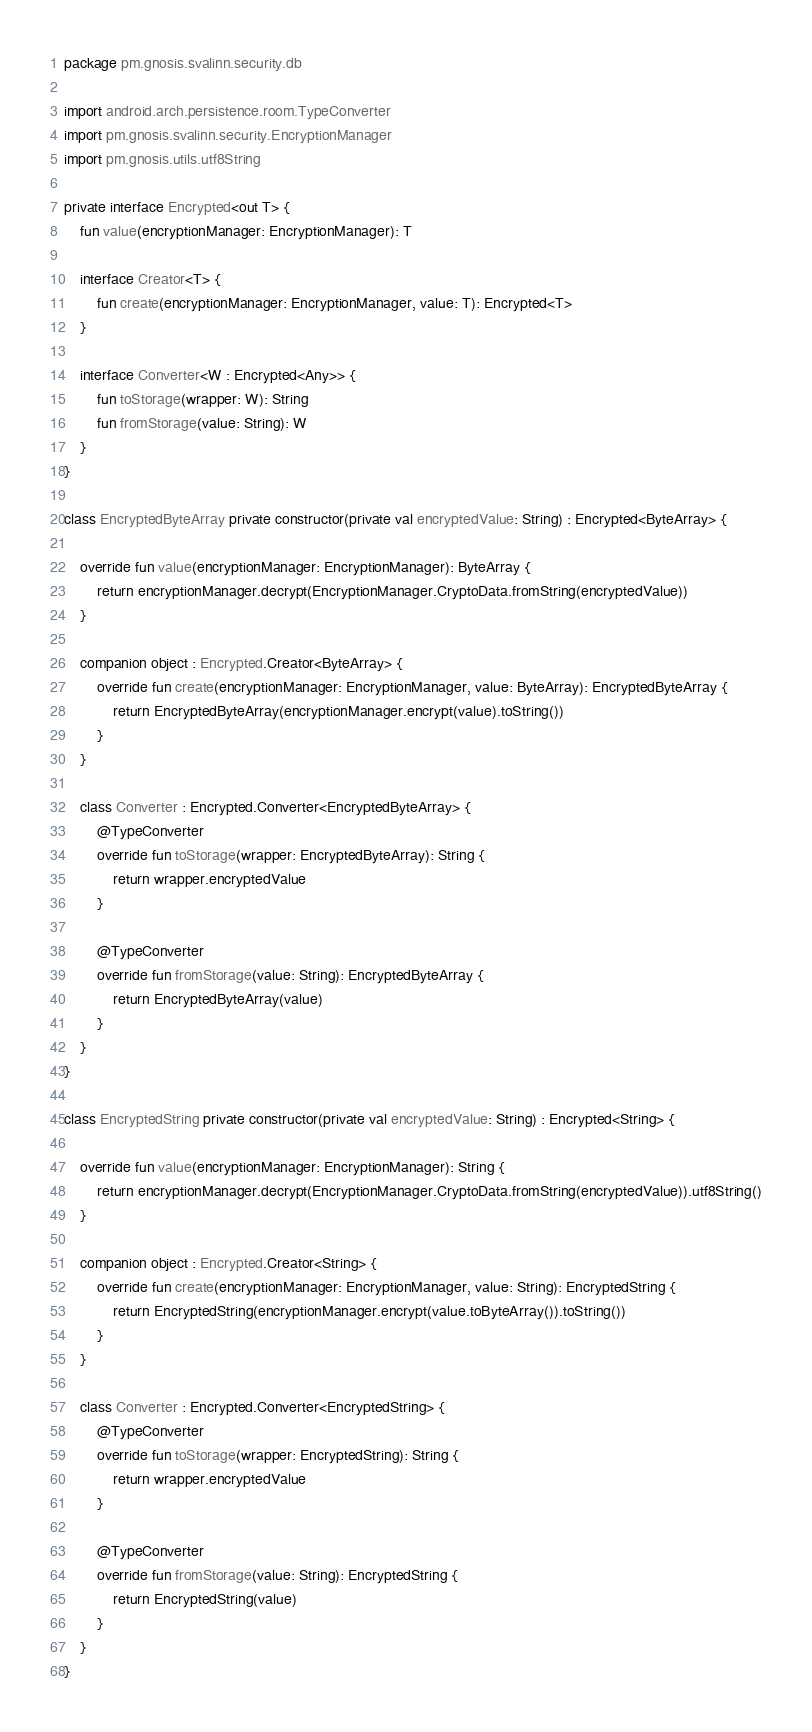<code> <loc_0><loc_0><loc_500><loc_500><_Kotlin_>package pm.gnosis.svalinn.security.db

import android.arch.persistence.room.TypeConverter
import pm.gnosis.svalinn.security.EncryptionManager
import pm.gnosis.utils.utf8String

private interface Encrypted<out T> {
    fun value(encryptionManager: EncryptionManager): T

    interface Creator<T> {
        fun create(encryptionManager: EncryptionManager, value: T): Encrypted<T>
    }

    interface Converter<W : Encrypted<Any>> {
        fun toStorage(wrapper: W): String
        fun fromStorage(value: String): W
    }
}

class EncryptedByteArray private constructor(private val encryptedValue: String) : Encrypted<ByteArray> {

    override fun value(encryptionManager: EncryptionManager): ByteArray {
        return encryptionManager.decrypt(EncryptionManager.CryptoData.fromString(encryptedValue))
    }

    companion object : Encrypted.Creator<ByteArray> {
        override fun create(encryptionManager: EncryptionManager, value: ByteArray): EncryptedByteArray {
            return EncryptedByteArray(encryptionManager.encrypt(value).toString())
        }
    }

    class Converter : Encrypted.Converter<EncryptedByteArray> {
        @TypeConverter
        override fun toStorage(wrapper: EncryptedByteArray): String {
            return wrapper.encryptedValue
        }

        @TypeConverter
        override fun fromStorage(value: String): EncryptedByteArray {
            return EncryptedByteArray(value)
        }
    }
}

class EncryptedString private constructor(private val encryptedValue: String) : Encrypted<String> {

    override fun value(encryptionManager: EncryptionManager): String {
        return encryptionManager.decrypt(EncryptionManager.CryptoData.fromString(encryptedValue)).utf8String()
    }

    companion object : Encrypted.Creator<String> {
        override fun create(encryptionManager: EncryptionManager, value: String): EncryptedString {
            return EncryptedString(encryptionManager.encrypt(value.toByteArray()).toString())
        }
    }

    class Converter : Encrypted.Converter<EncryptedString> {
        @TypeConverter
        override fun toStorage(wrapper: EncryptedString): String {
            return wrapper.encryptedValue
        }

        @TypeConverter
        override fun fromStorage(value: String): EncryptedString {
            return EncryptedString(value)
        }
    }
}</code> 